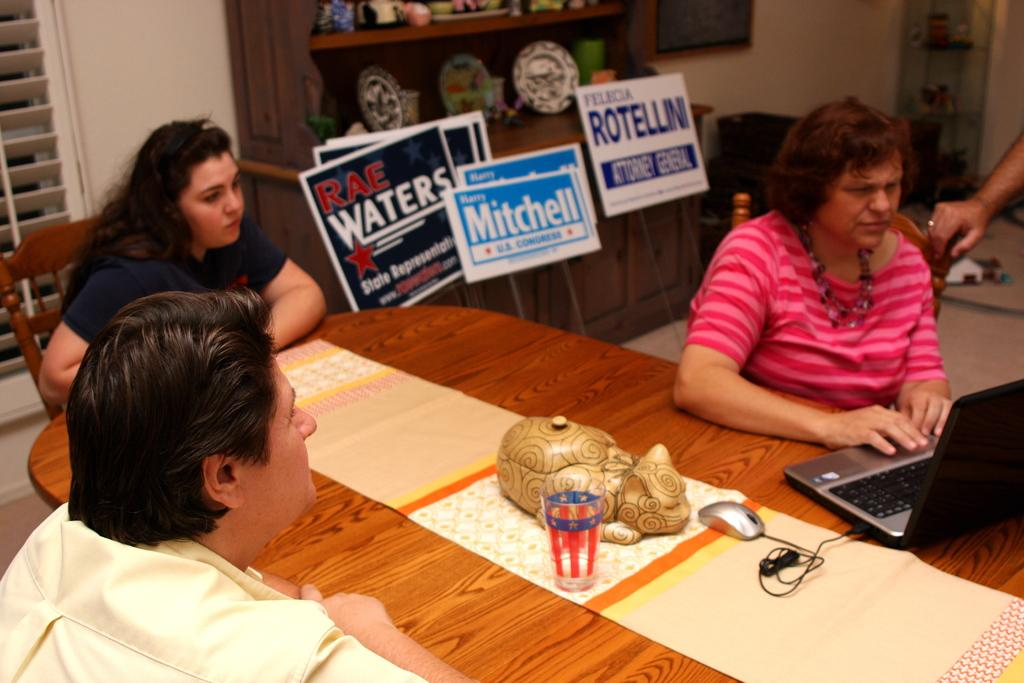How many people are sitting in the image? There are three people sitting on chairs in the image. What can be seen on the table in the image? There is a glass, a laptop, and a mouse on the table in the image. What is visible in the background of the image? There are boards and a cupboard in the background of the image. Can you see a notebook in the quicksand in the image? There is no quicksand or notebook present in the image. Is there a tent visible in the image? There is no tent present in the image. 